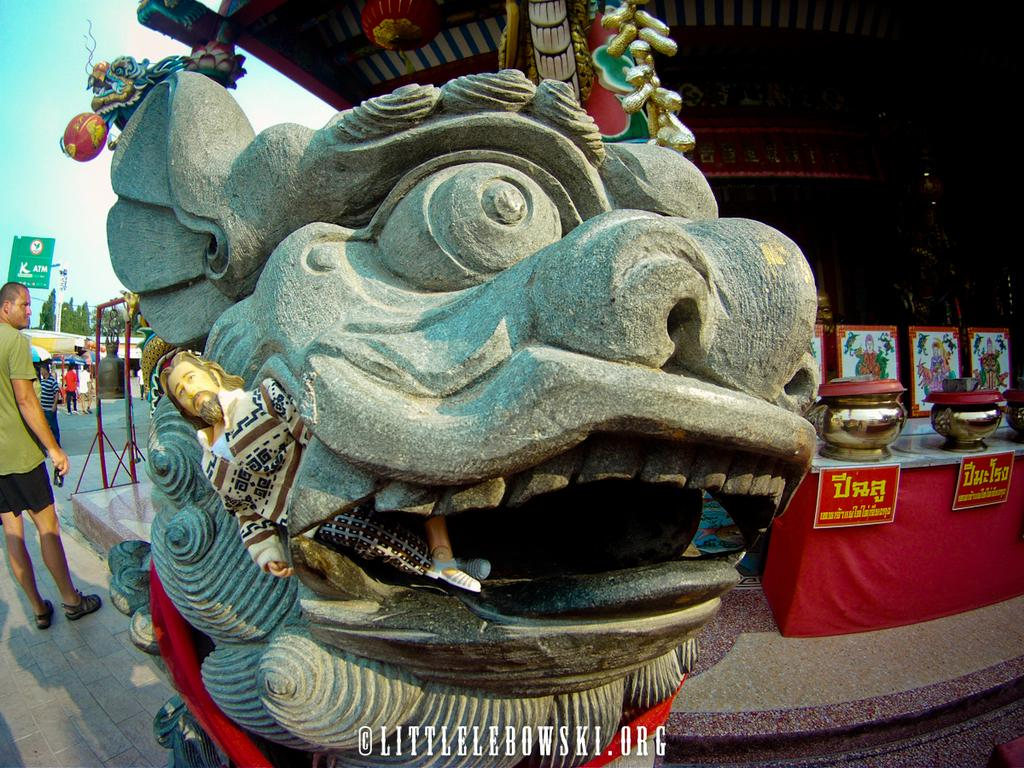What is the main subject of the image? There is a sculpture of a monster in the image. What is located behind the sculpture? There is a food stall behind the sculpture. What can be seen on the left side of the image? People are walking beside the food stall on the left side of the image. How much blood is visible on the monster's claws in the image? There is no blood visible on the monster's claws in the image, as the sculpture is not depicted as being bloody or violent. What type of scissors are being used by the monster to cut the food at the stall? There are no scissors present in the image, and the monster is not depicted as cutting food at the stall. 